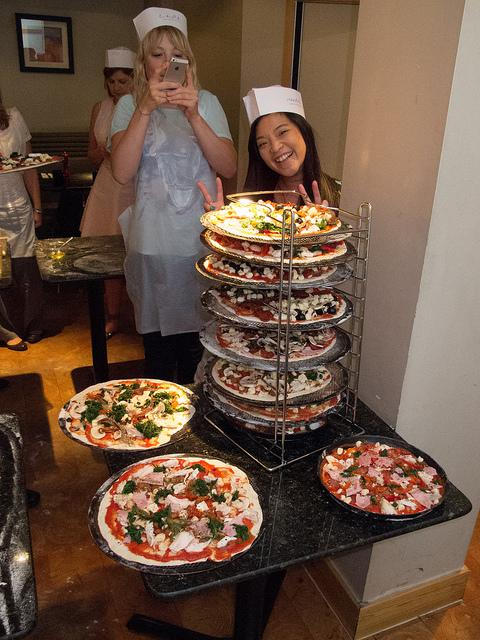What will these ladies next do with the pizzas? bake 